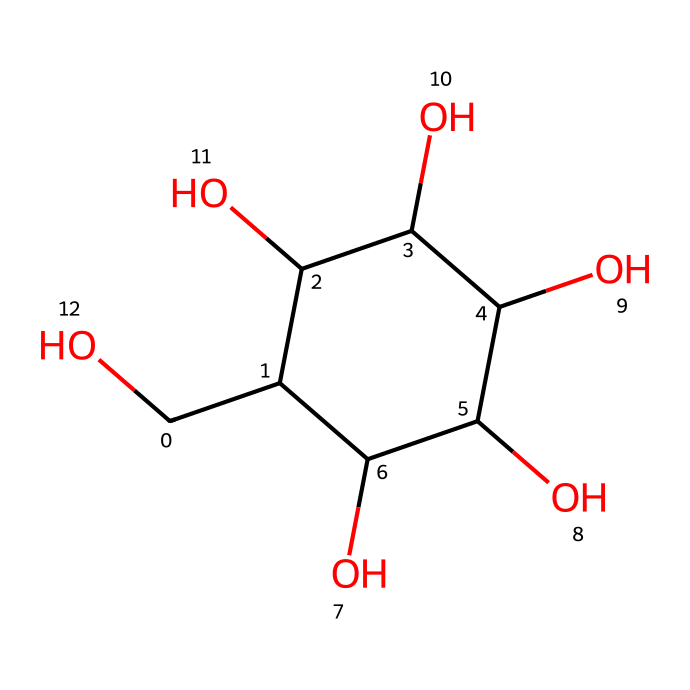What is the molecular formula of glucose? By analyzing the structure given by the SMILES notation, we can count the number of carbon (C), hydrogen (H), and oxygen (O) atoms present. In this case, there are 6 carbon atoms, 12 hydrogen atoms, and 6 oxygen atoms, leading to the molecular formula C6H12O6.
Answer: C6H12O6 How many hydroxyl (–OH) groups are there in the structure? In the chemical structure derived from the SMILES, we can identify the hydroxyl groups, which are characterized by the –OH functional groups. Counting the –OH groups in the structure reveals that there are 5 such groups.
Answer: 5 What type of carbohydrate is glucose classified as? Based on the structure and the presence of multiple hydroxyl groups along with its ring form, we can classify glucose as a monosaccharide, which is a single sugar unit.
Answer: monosaccharide What is the total number of rings in the glucose structure? Observing the SMILES notation, we can see that it contains a cyclic structure, implying a ring formation. This denotes that glucose has one ring in its structure, characteristic of its cyclic form.
Answer: 1 How many carbon atoms are linked directly to hydroxyl groups? In the given representation, we analyze the carbon atoms and their connectivity. Each carbon atom, except for the one in the structure's backbone, is directly attached to one or more hydroxyl groups, leading to the fact that 5 carbon atoms have hydroxyl groups attached to them.
Answer: 5 What is the primary functional group present in glucose? From our analysis of the structure, the hydroxyl groups (–OH) are the dominant functional groups that characterize glucose. They are responsible for its solubility in water and its reactivity.
Answer: hydroxyl group 